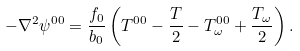Convert formula to latex. <formula><loc_0><loc_0><loc_500><loc_500>- \nabla ^ { 2 } \psi ^ { 0 0 } = \frac { f _ { 0 } } { b _ { 0 } } \left ( T ^ { 0 0 } - \frac { T } { 2 } - T _ { \omega } ^ { 0 0 } + \frac { T _ { \omega } } { 2 } \right ) .</formula> 